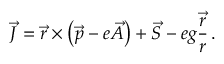<formula> <loc_0><loc_0><loc_500><loc_500>\vec { J } = \vec { r } \times \left ( \vec { p } - e \vec { A } \right ) + \vec { S } - e g \frac { \vec { r } } { r } \, .</formula> 